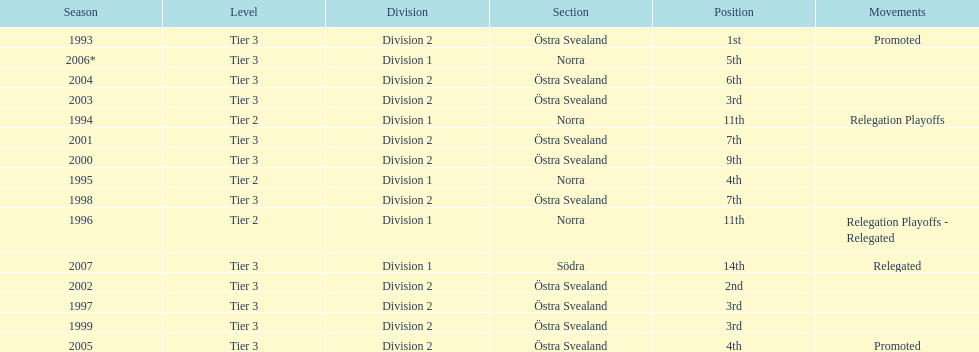In what season did visby if gute fk finish first in division 2 tier 3? 1993. 